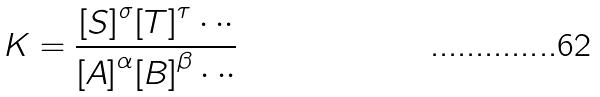Convert formula to latex. <formula><loc_0><loc_0><loc_500><loc_500>K = \frac { { [ S ] } ^ { \sigma } { [ T ] } ^ { \tau } \cdot \cdot \cdot } { { [ A ] } ^ { \alpha } { [ B ] } ^ { \beta } \cdot \cdot \cdot }</formula> 